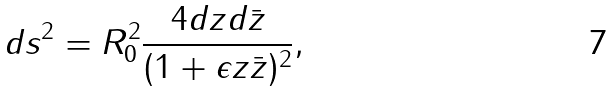Convert formula to latex. <formula><loc_0><loc_0><loc_500><loc_500>d s ^ { 2 } = R _ { 0 } ^ { 2 } \frac { 4 d z d \bar { z } } { ( 1 + \epsilon { z \bar { z } } ) ^ { 2 } } ,</formula> 